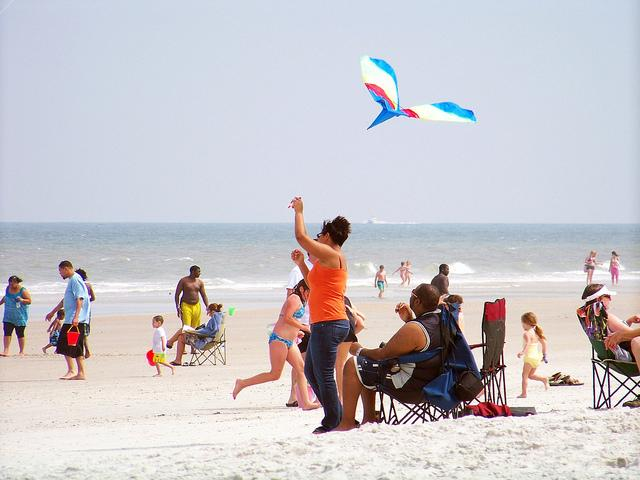What is missing in the picture that is typical at beaches? umbrellas 